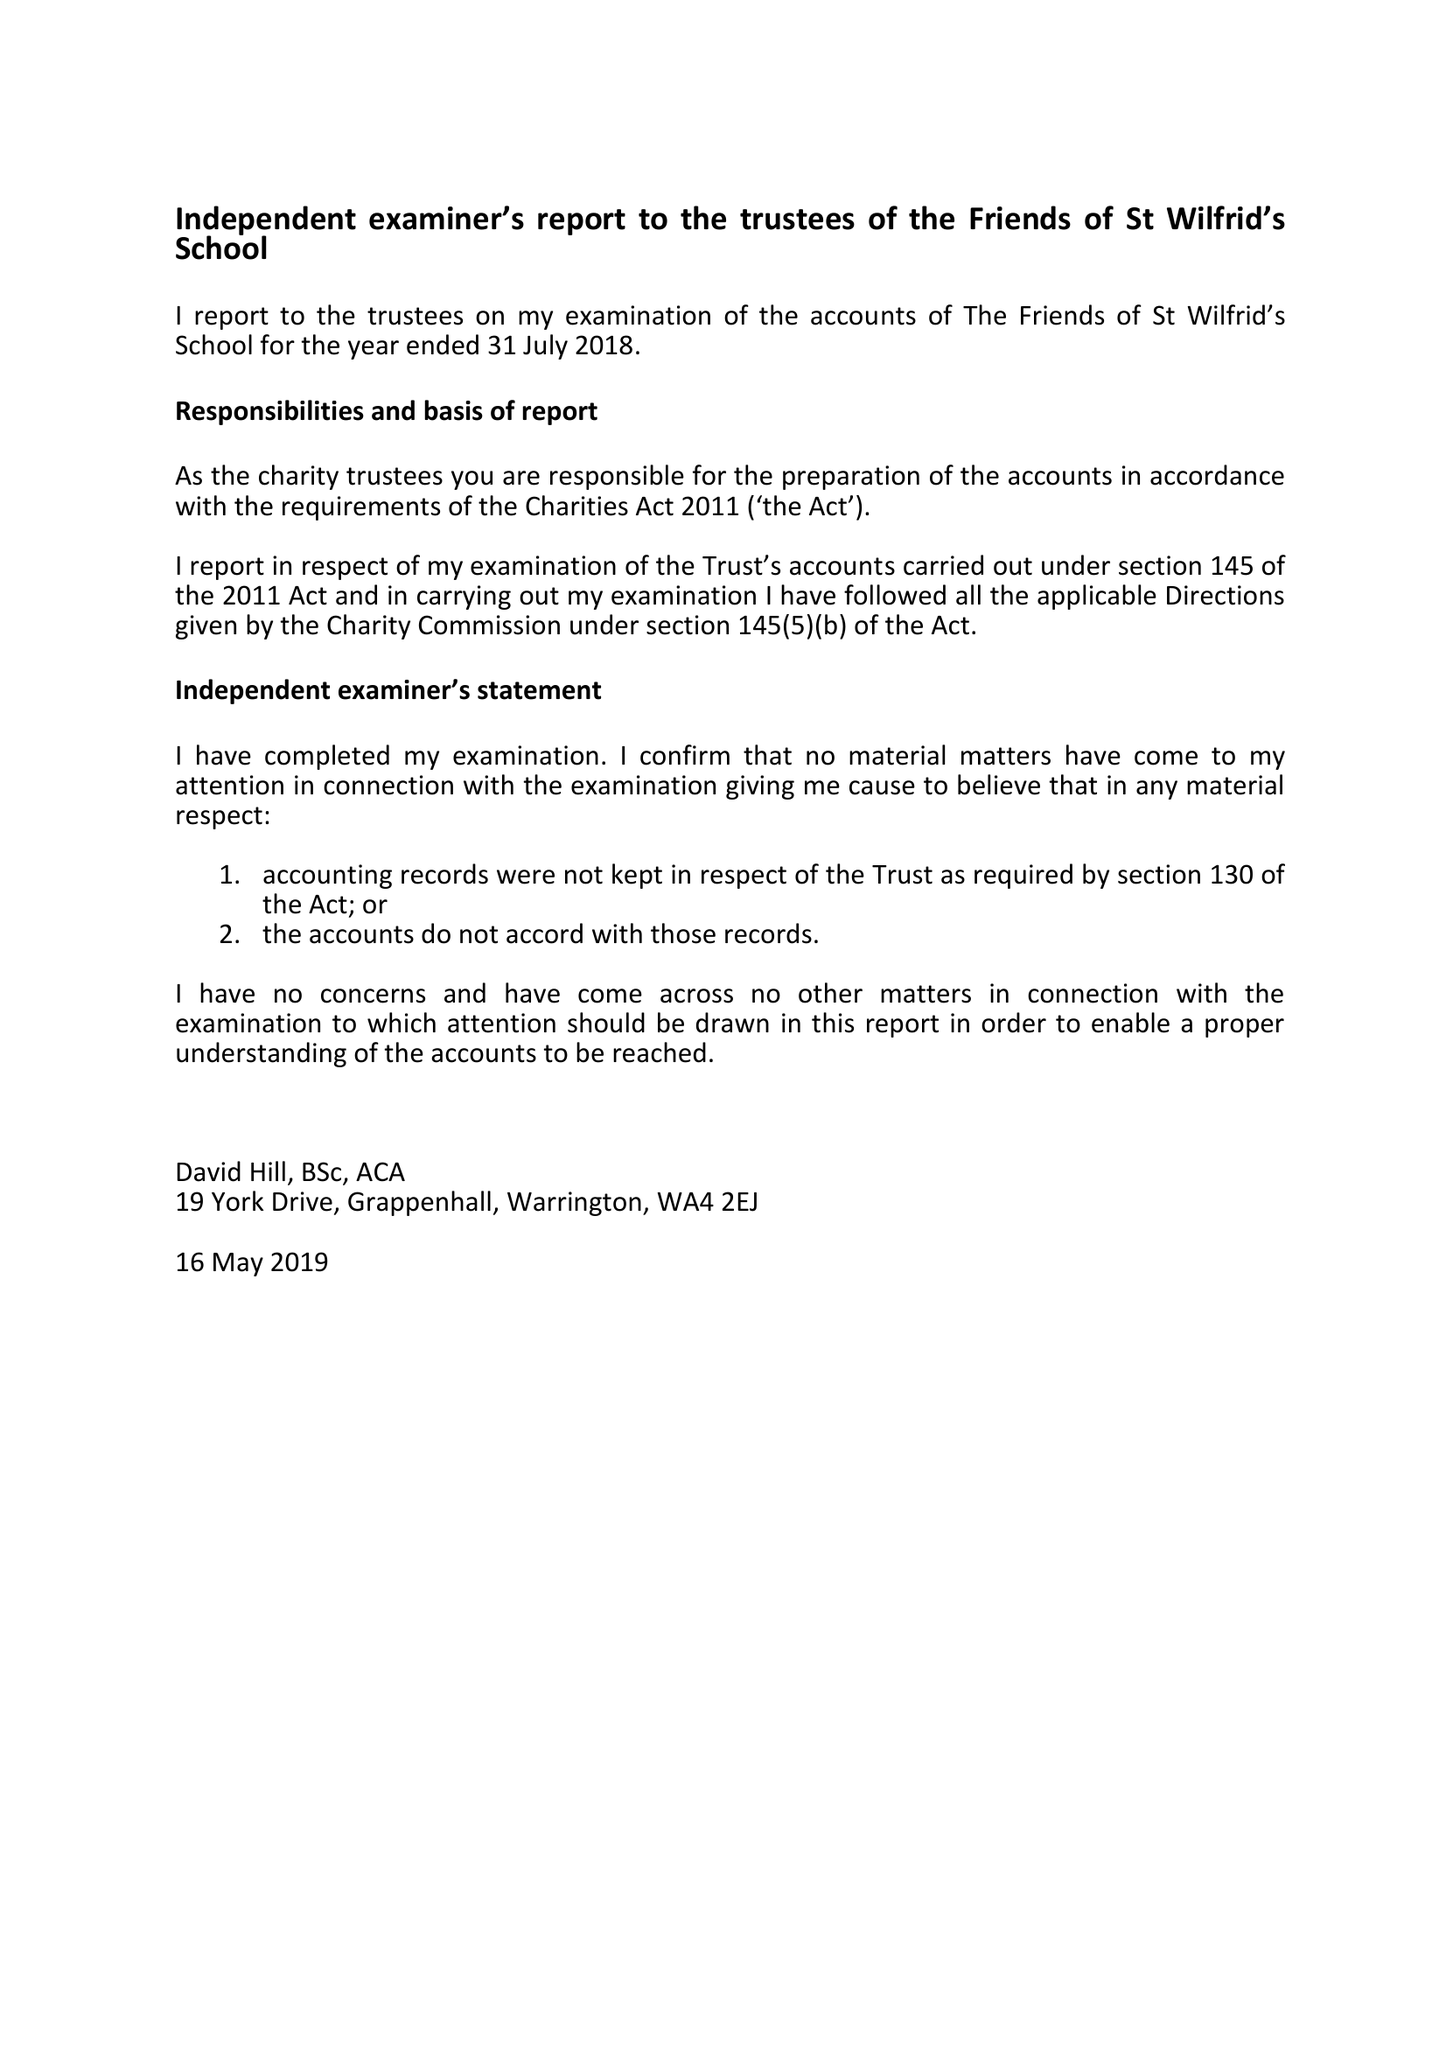What is the value for the address__post_town?
Answer the question using a single word or phrase. WARRINGTON 